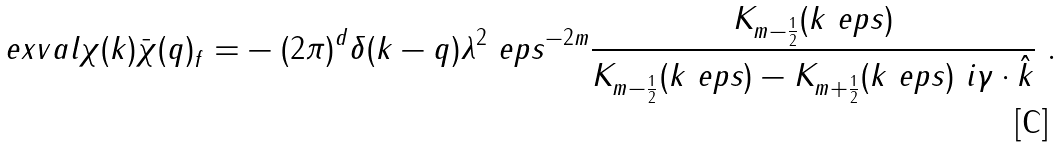<formula> <loc_0><loc_0><loc_500><loc_500>\ e x v a l { \chi ( k ) \bar { \chi } ( q ) } _ { f } = & - ( 2 \pi ) ^ { d } \delta ( k - q ) \lambda ^ { 2 } \ e p s ^ { - 2 m } \frac { K _ { m - \frac { 1 } { 2 } } ( k \ e p s ) } { K _ { m - \frac { 1 } { 2 } } ( k \ e p s ) - K _ { m + \frac { 1 } { 2 } } ( k \ e p s ) \ i \gamma \cdot \hat { k } } \ .</formula> 